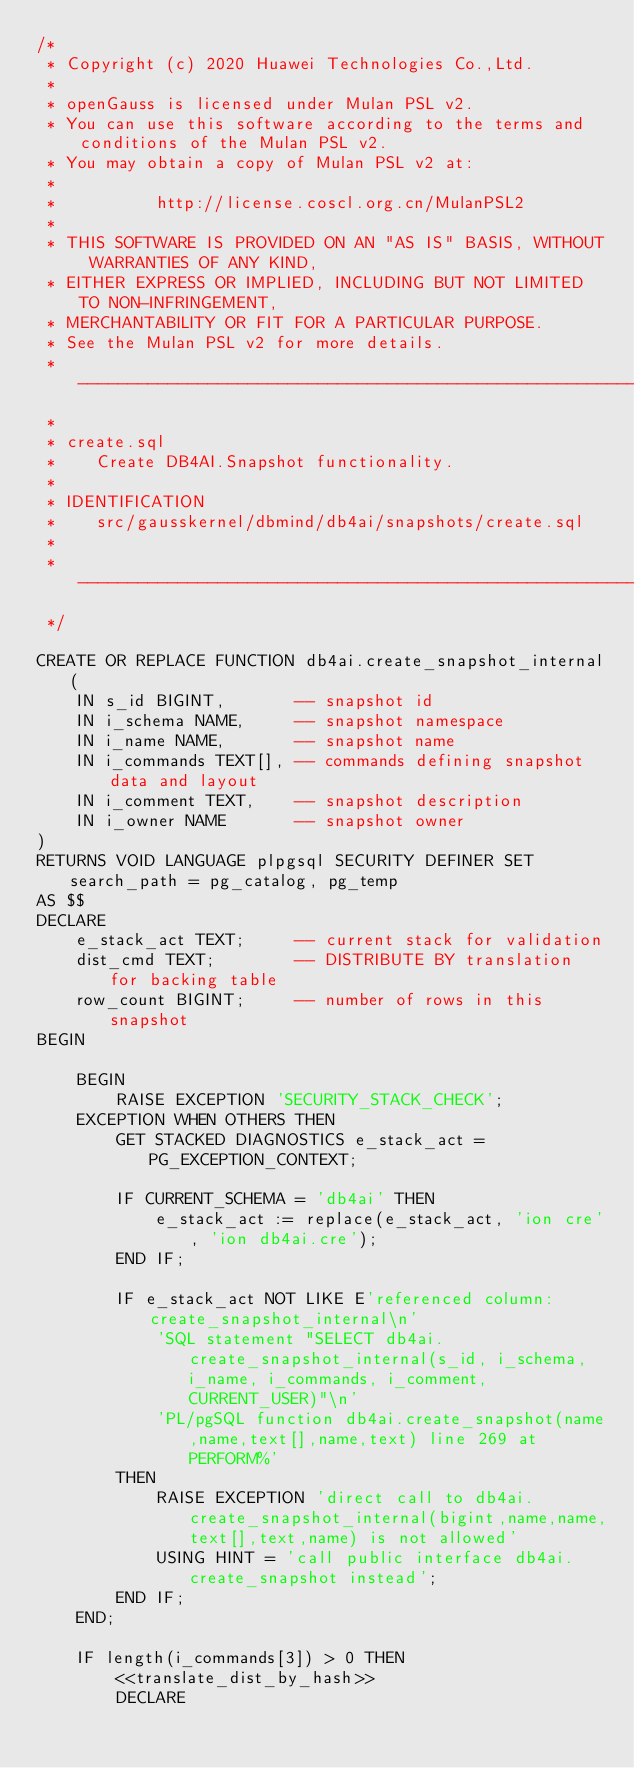Convert code to text. <code><loc_0><loc_0><loc_500><loc_500><_SQL_>/*
 * Copyright (c) 2020 Huawei Technologies Co.,Ltd.
 *
 * openGauss is licensed under Mulan PSL v2.
 * You can use this software according to the terms and conditions of the Mulan PSL v2.
 * You may obtain a copy of Mulan PSL v2 at:
 *
 *          http://license.coscl.org.cn/MulanPSL2
 *
 * THIS SOFTWARE IS PROVIDED ON AN "AS IS" BASIS, WITHOUT WARRANTIES OF ANY KIND,
 * EITHER EXPRESS OR IMPLIED, INCLUDING BUT NOT LIMITED TO NON-INFRINGEMENT,
 * MERCHANTABILITY OR FIT FOR A PARTICULAR PURPOSE.
 * See the Mulan PSL v2 for more details.
 * -------------------------------------------------------------------------
 *
 * create.sql
 *    Create DB4AI.Snapshot functionality.
 *
 * IDENTIFICATION
 *    src/gausskernel/dbmind/db4ai/snapshots/create.sql
 *
 * -------------------------------------------------------------------------
 */

CREATE OR REPLACE FUNCTION db4ai.create_snapshot_internal(
    IN s_id BIGINT,       -- snapshot id
    IN i_schema NAME,     -- snapshot namespace
    IN i_name NAME,       -- snapshot name
    IN i_commands TEXT[], -- commands defining snapshot data and layout
    IN i_comment TEXT,    -- snapshot description
    IN i_owner NAME       -- snapshot owner
)
RETURNS VOID LANGUAGE plpgsql SECURITY DEFINER SET search_path = pg_catalog, pg_temp
AS $$
DECLARE
    e_stack_act TEXT;     -- current stack for validation
    dist_cmd TEXT;        -- DISTRIBUTE BY translation for backing table
    row_count BIGINT;     -- number of rows in this snapshot
BEGIN

    BEGIN
        RAISE EXCEPTION 'SECURITY_STACK_CHECK';
    EXCEPTION WHEN OTHERS THEN
        GET STACKED DIAGNOSTICS e_stack_act = PG_EXCEPTION_CONTEXT;

        IF CURRENT_SCHEMA = 'db4ai' THEN
            e_stack_act := replace(e_stack_act, 'ion cre', 'ion db4ai.cre');
        END IF;
        
        IF e_stack_act NOT LIKE E'referenced column: create_snapshot_internal\n'
            'SQL statement "SELECT db4ai.create_snapshot_internal(s_id, i_schema, i_name, i_commands, i_comment, CURRENT_USER)"\n'
            'PL/pgSQL function db4ai.create_snapshot(name,name,text[],name,text) line 269 at PERFORM%'
        THEN
            RAISE EXCEPTION 'direct call to db4ai.create_snapshot_internal(bigint,name,name,text[],text,name) is not allowed'
            USING HINT = 'call public interface db4ai.create_snapshot instead';
        END IF;
    END;

    IF length(i_commands[3]) > 0 THEN
        <<translate_dist_by_hash>>
        DECLARE</code> 